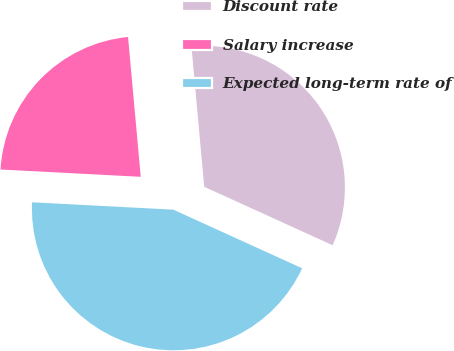Convert chart. <chart><loc_0><loc_0><loc_500><loc_500><pie_chart><fcel>Discount rate<fcel>Salary increase<fcel>Expected long-term rate of<nl><fcel>33.24%<fcel>22.73%<fcel>44.03%<nl></chart> 